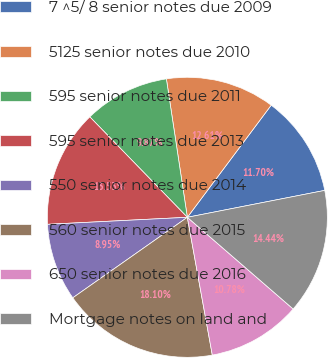<chart> <loc_0><loc_0><loc_500><loc_500><pie_chart><fcel>7 ^5/ 8 senior notes due 2009<fcel>5125 senior notes due 2010<fcel>595 senior notes due 2011<fcel>595 senior notes due 2013<fcel>550 senior notes due 2014<fcel>560 senior notes due 2015<fcel>650 senior notes due 2016<fcel>Mortgage notes on land and<nl><fcel>11.7%<fcel>12.61%<fcel>9.87%<fcel>13.53%<fcel>8.95%<fcel>18.1%<fcel>10.78%<fcel>14.44%<nl></chart> 